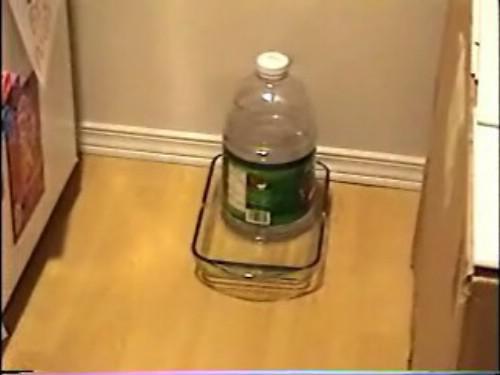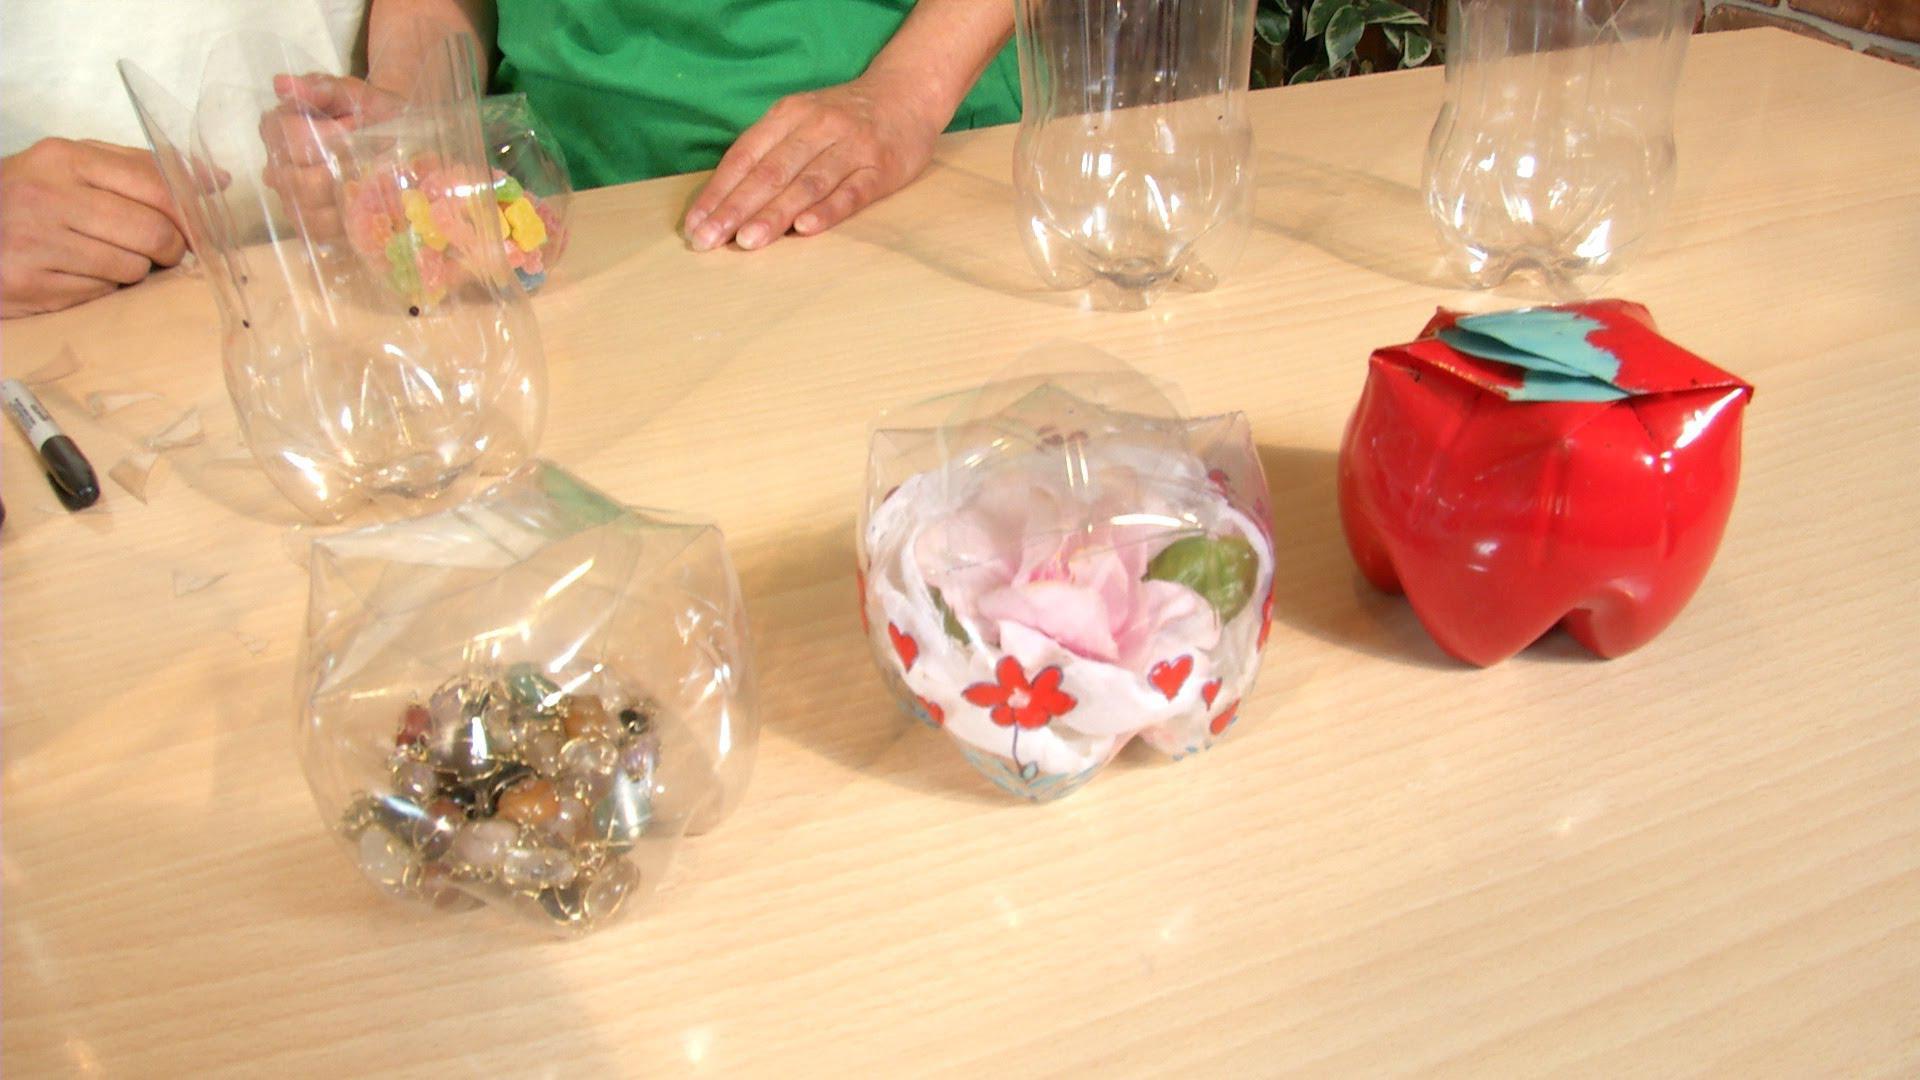The first image is the image on the left, the second image is the image on the right. For the images shown, is this caption "In one of the images, the plastic bottles have been remade into containers that look like apples." true? Answer yes or no. Yes. The first image is the image on the left, the second image is the image on the right. Evaluate the accuracy of this statement regarding the images: "The right image shows something holding a green bottle horizontally with its top end to the right.". Is it true? Answer yes or no. No. 